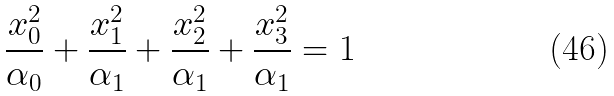<formula> <loc_0><loc_0><loc_500><loc_500>\frac { x _ { 0 } ^ { 2 } } { \alpha _ { 0 } } + \frac { x _ { 1 } ^ { 2 } } { \alpha _ { 1 } } + \frac { x _ { 2 } ^ { 2 } } { \alpha _ { 1 } } + \frac { x _ { 3 } ^ { 2 } } { \alpha _ { 1 } } = 1</formula> 